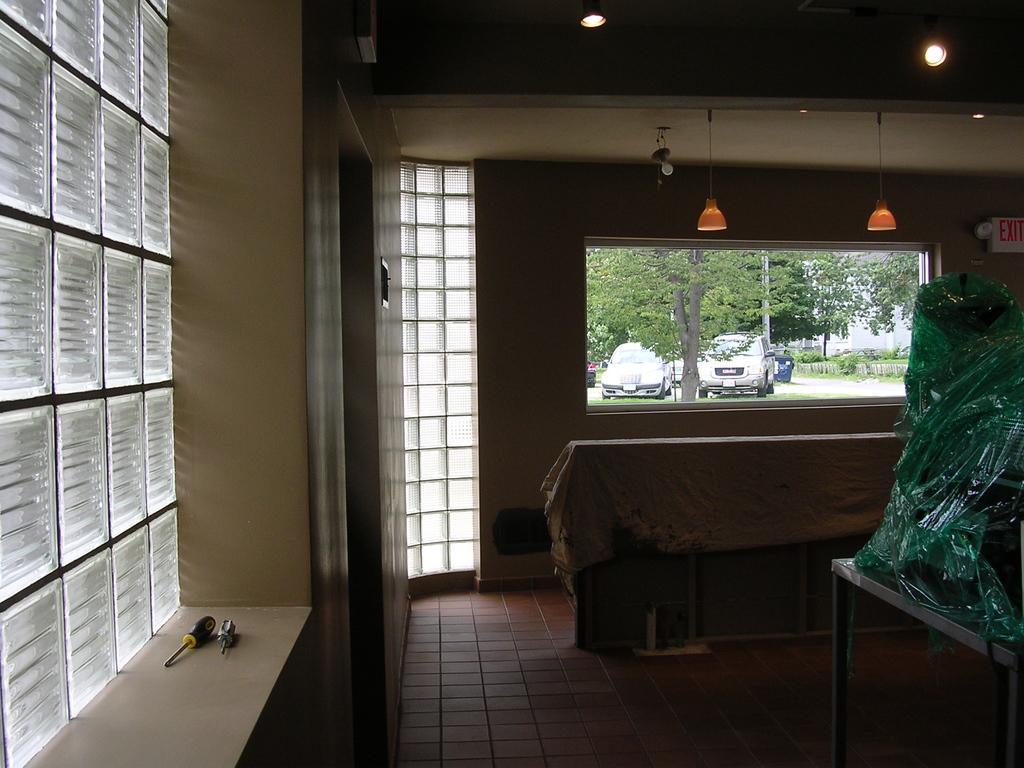How would you summarize this image in a sentence or two? In this image we can see an inside view of a building, there is a window and few objects on the window, there are lights attached to the ceiling, and there are cars and trees outside the building. 